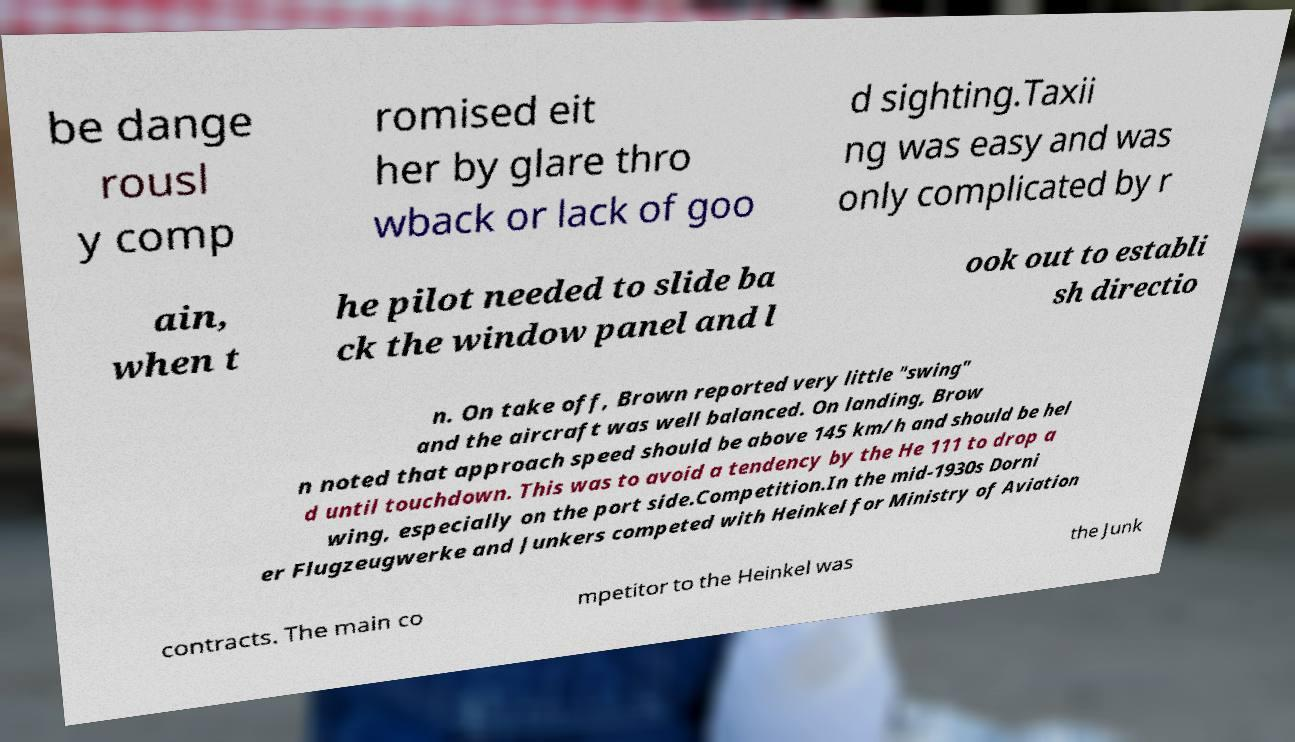I need the written content from this picture converted into text. Can you do that? be dange rousl y comp romised eit her by glare thro wback or lack of goo d sighting.Taxii ng was easy and was only complicated by r ain, when t he pilot needed to slide ba ck the window panel and l ook out to establi sh directio n. On take off, Brown reported very little "swing" and the aircraft was well balanced. On landing, Brow n noted that approach speed should be above 145 km/h and should be hel d until touchdown. This was to avoid a tendency by the He 111 to drop a wing, especially on the port side.Competition.In the mid-1930s Dorni er Flugzeugwerke and Junkers competed with Heinkel for Ministry of Aviation contracts. The main co mpetitor to the Heinkel was the Junk 